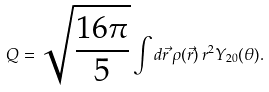Convert formula to latex. <formula><loc_0><loc_0><loc_500><loc_500>Q = \sqrt { \frac { 1 6 \pi } { 5 } } \int d \vec { r } \, \rho ( \vec { r } ) \, r ^ { 2 } Y _ { 2 0 } ( \theta ) .</formula> 